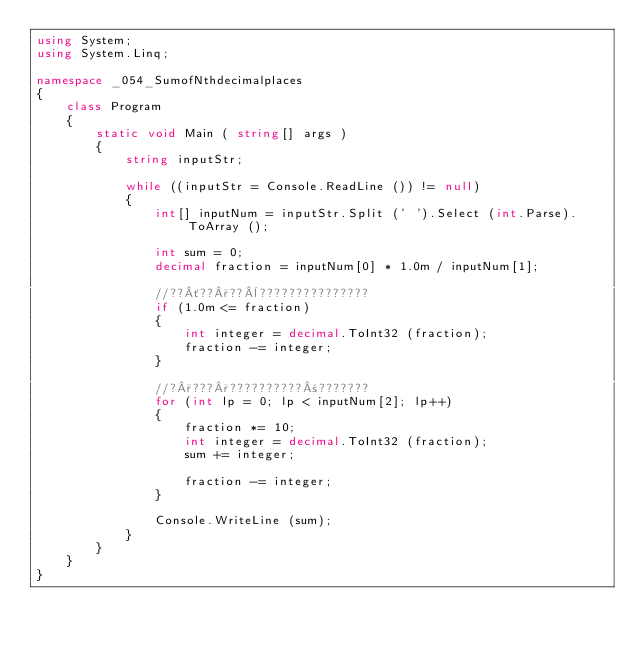Convert code to text. <code><loc_0><loc_0><loc_500><loc_500><_C#_>using System;
using System.Linq;

namespace _054_SumofNthdecimalplaces
{
	class Program
	{
		static void Main ( string[] args )
		{
			string inputStr;

			while ((inputStr = Console.ReadLine ()) != null)
			{
				int[] inputNum = inputStr.Split (' ').Select (int.Parse).ToArray ();

				int sum = 0;
				decimal fraction = inputNum[0] * 1.0m / inputNum[1];

				//??´??°??¨???????????????
				if (1.0m <= fraction)
				{
					int integer = decimal.ToInt32 (fraction);
					fraction -= integer;
				}

				//?°???°??????????±???????
				for (int lp = 0; lp < inputNum[2]; lp++)
				{
					fraction *= 10;
					int integer = decimal.ToInt32 (fraction);
					sum += integer;
					
					fraction -= integer;
				}

				Console.WriteLine (sum);
			}
		}
	}
}</code> 